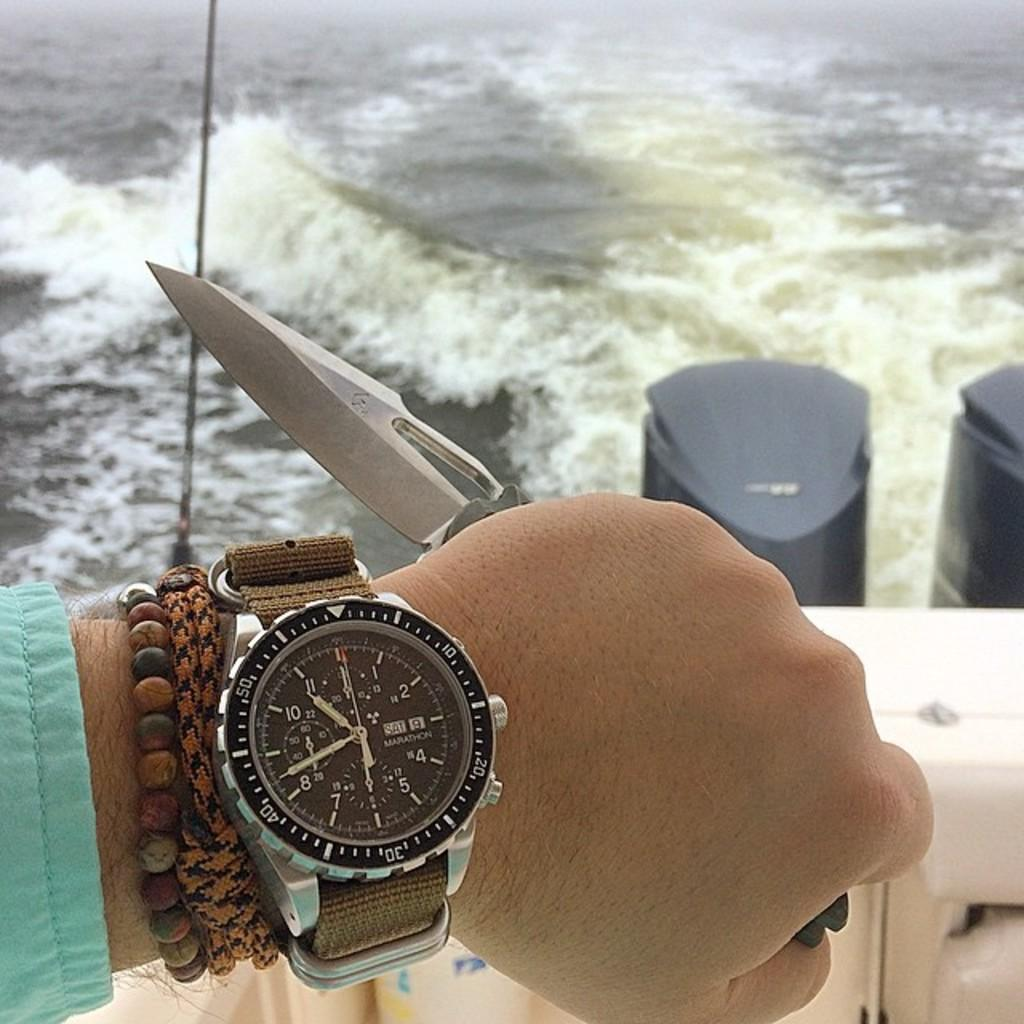What is visible in the image that is not a part of the person's hand? There is water visible in the image. What can be seen on the person's hand in the image? The person's hand is wearing a wrist watch and bracelets. What is the person's hand holding in the image? The person's hand is holding a knife. How many ladybugs can be seen on the person's hand in the image? There are no ladybugs present on the person's hand in the image. What is the end result of the person's hand holding the knife in the image? The image does not show the end result of the person's hand holding the knife, as it only captures a moment in time. 